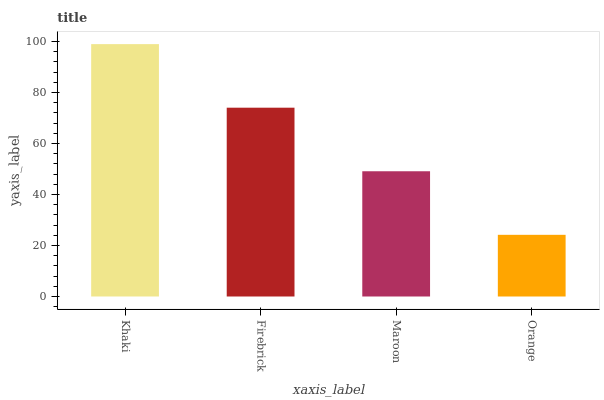Is Orange the minimum?
Answer yes or no. Yes. Is Khaki the maximum?
Answer yes or no. Yes. Is Firebrick the minimum?
Answer yes or no. No. Is Firebrick the maximum?
Answer yes or no. No. Is Khaki greater than Firebrick?
Answer yes or no. Yes. Is Firebrick less than Khaki?
Answer yes or no. Yes. Is Firebrick greater than Khaki?
Answer yes or no. No. Is Khaki less than Firebrick?
Answer yes or no. No. Is Firebrick the high median?
Answer yes or no. Yes. Is Maroon the low median?
Answer yes or no. Yes. Is Orange the high median?
Answer yes or no. No. Is Firebrick the low median?
Answer yes or no. No. 